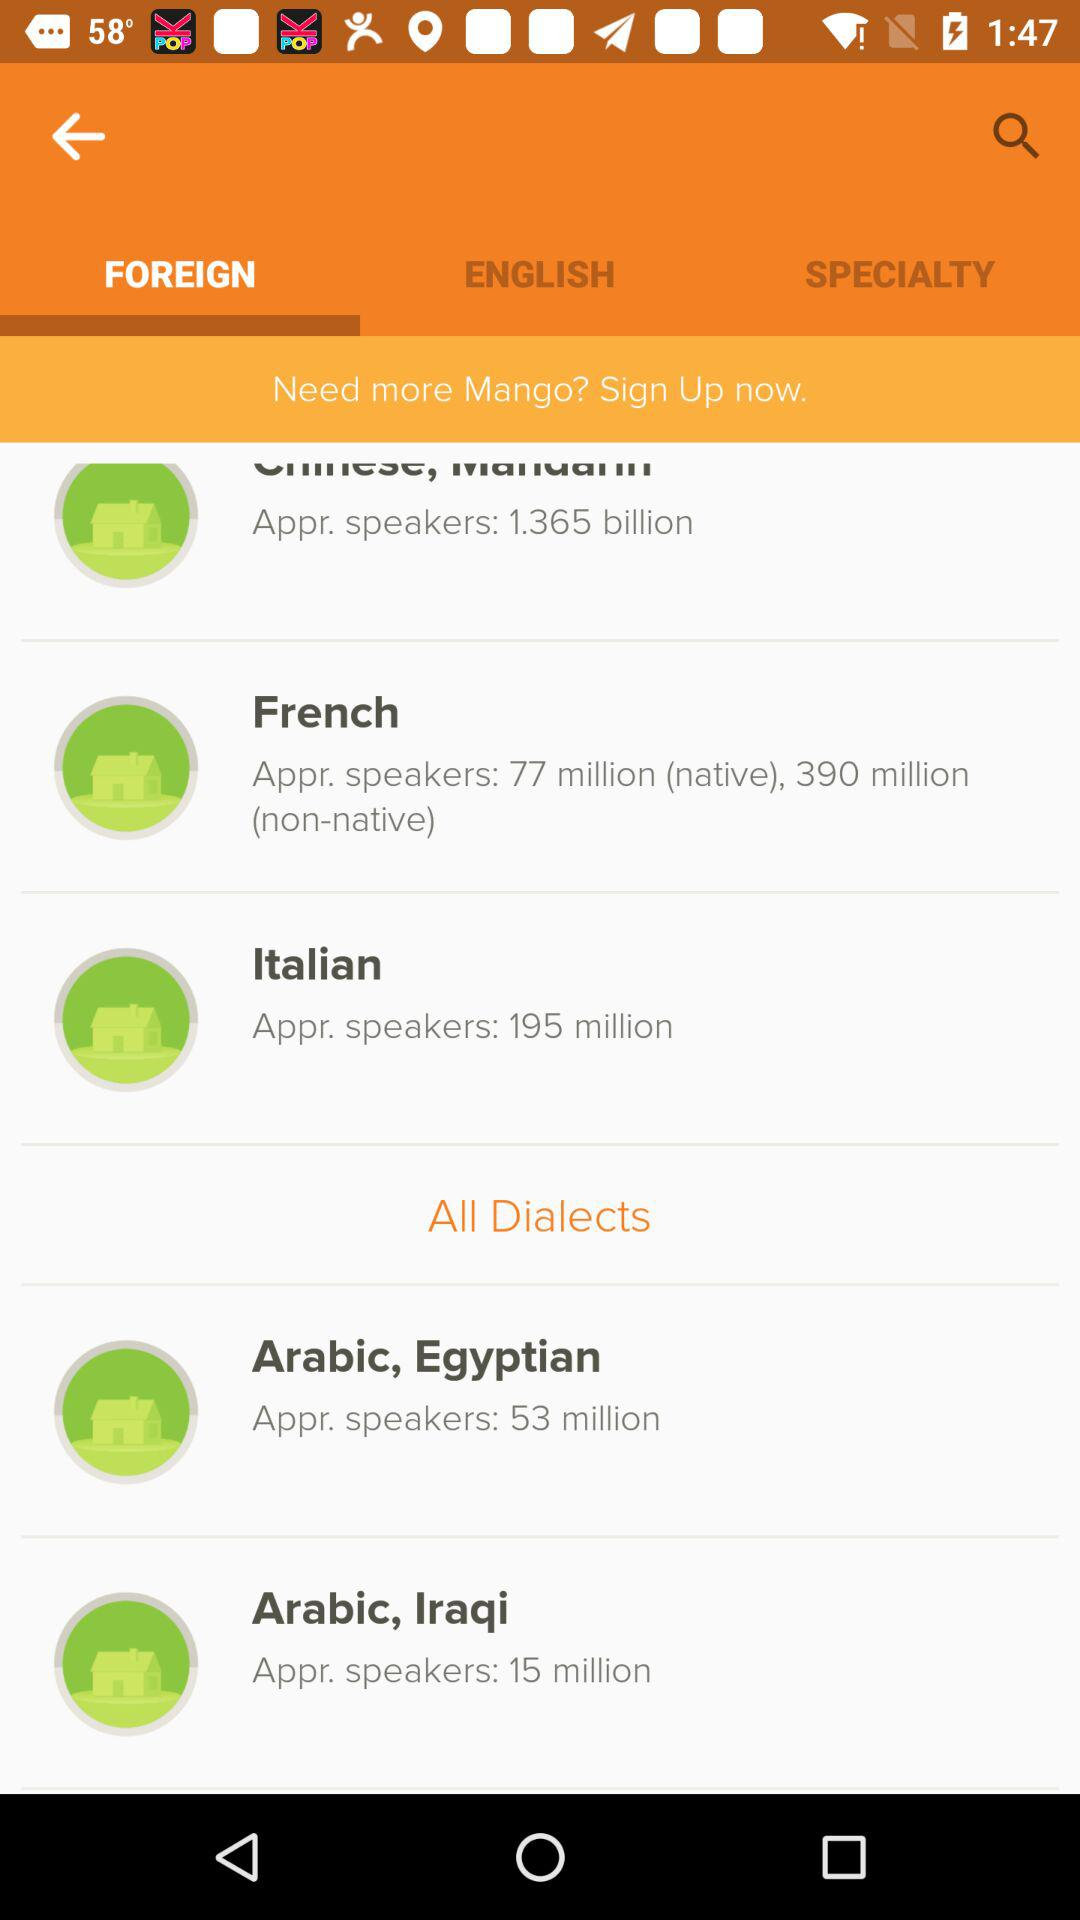How many more speakers does Arabic, Egyptian have than Arabic, Iraqi?
Answer the question using a single word or phrase. 38 